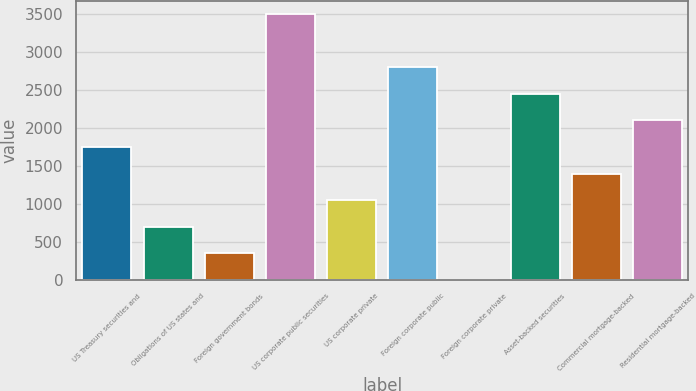Convert chart. <chart><loc_0><loc_0><loc_500><loc_500><bar_chart><fcel>US Treasury securities and<fcel>Obligations of US states and<fcel>Foreign government bonds<fcel>US corporate public securities<fcel>US corporate private<fcel>Foreign corporate public<fcel>Foreign corporate private<fcel>Asset-backed securities<fcel>Commercial mortgage-backed<fcel>Residential mortgage-backed<nl><fcel>1748.57<fcel>700.13<fcel>350.65<fcel>3495.97<fcel>1049.61<fcel>2797.01<fcel>1.17<fcel>2447.53<fcel>1399.09<fcel>2098.05<nl></chart> 